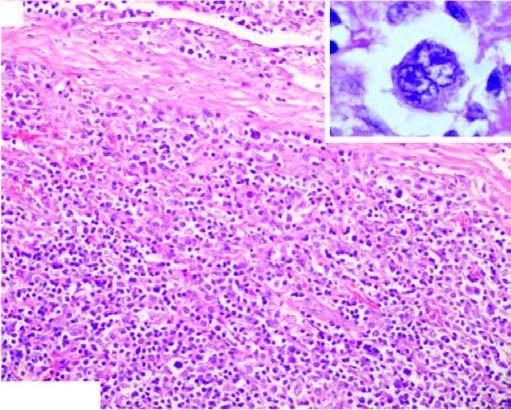where is admixture of mature lymphocytes, plasma cells, neutrophils and eosinophils and classic rs cells?
Answer the question using a single word or phrase. In the centre of the field 